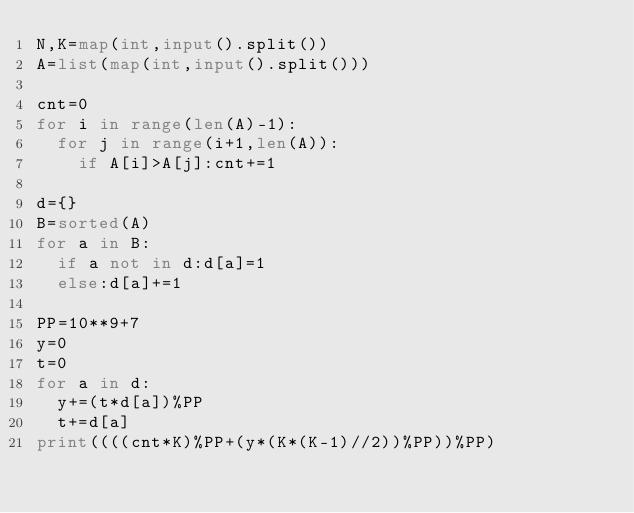<code> <loc_0><loc_0><loc_500><loc_500><_Python_>N,K=map(int,input().split())
A=list(map(int,input().split()))

cnt=0
for i in range(len(A)-1):
	for j in range(i+1,len(A)):
		if A[i]>A[j]:cnt+=1

d={}
B=sorted(A)
for a in B:
	if a not in d:d[a]=1
	else:d[a]+=1

PP=10**9+7
y=0
t=0
for a in d:
	y+=(t*d[a])%PP
	t+=d[a]
print((((cnt*K)%PP+(y*(K*(K-1)//2))%PP))%PP)
</code> 